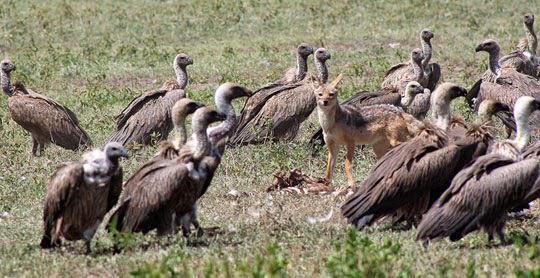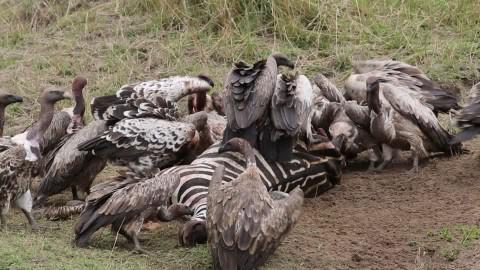The first image is the image on the left, the second image is the image on the right. For the images displayed, is the sentence "There is at least one bird with extended wings in the image on the right." factually correct? Answer yes or no. No. 